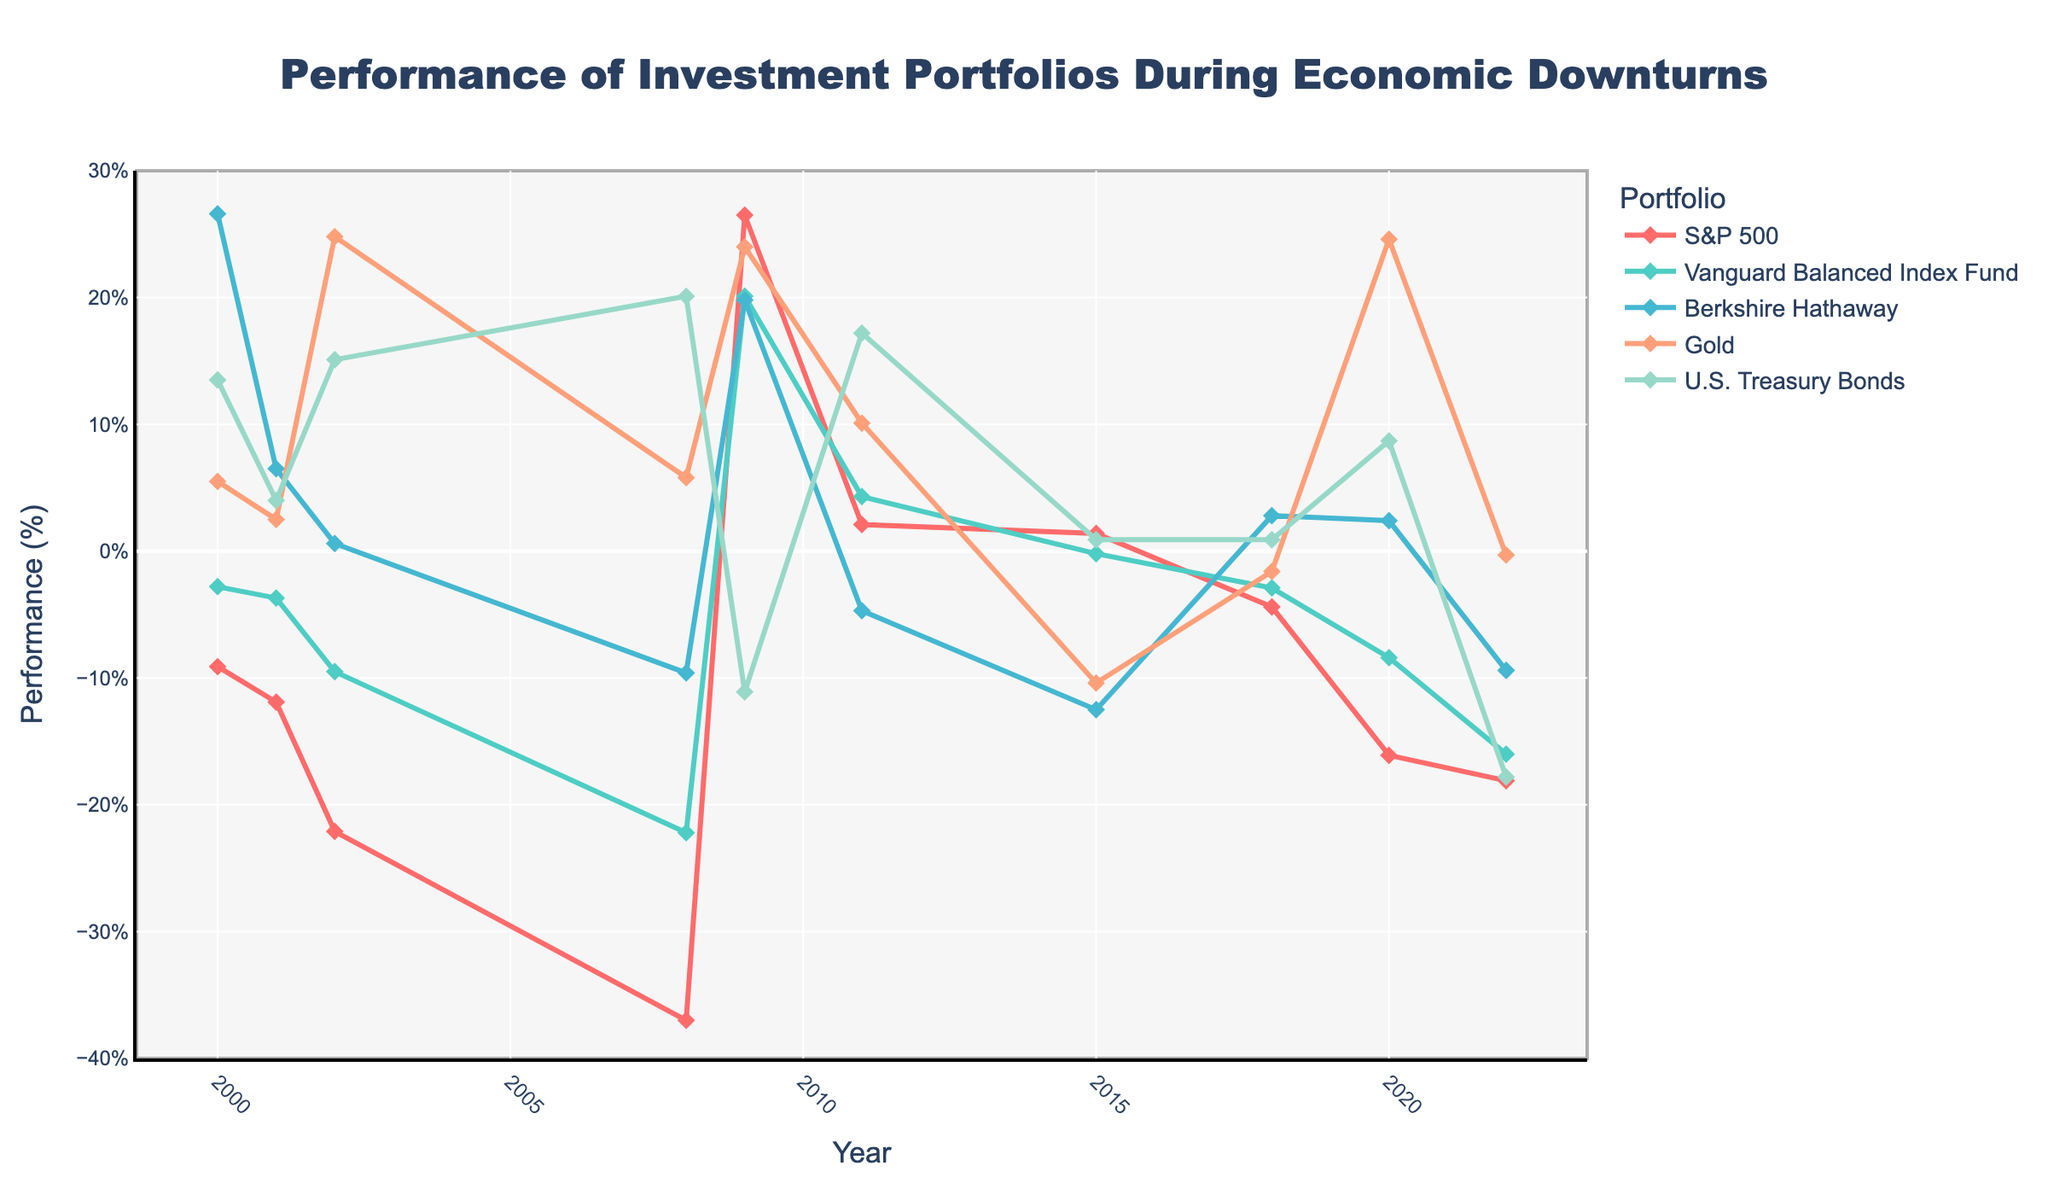Which portfolio had the highest performance in the year 2009? In the year 2009, inspect the data points for all portfolios. The one with the highest performance is the S&P 500 with a performance of 26.5%.
Answer: S&P 500 How did the performance of U.S. Treasury Bonds change from 2008 to 2009? Compare the U.S. Treasury Bonds data points for 2008 and 2009. In 2008, the performance was 20.1%, and in 2009, it was -11.1%. The performance decreased significantly.
Answer: Decreased What was the average performance of the Berkshire Hathaway portfolio during the highlighted years? Calculate the average by summing up the Berkshire Hathaway performances (-9.6, 19.8, -4.7, -12.5, 2.8, 2.4, -9.4) and dividing by the number of years (7). The sum is -11.2, and the average is -1.6%.
Answer: -1.6% Which year had the lowest performance for the S&P 500 portfolio? Look at the S&P 500 data points across all years. The lowest performance is -37.0% in the year 2008.
Answer: 2008 Compare the performance of Gold and U.S. Treasury Bonds in 2002. Which one performed better? For the year 2002, the performance of Gold is 24.8% and U.S. Treasury Bonds is 15.1%. Gold performed better.
Answer: Gold In how many years did Vanguard Balanced Index Fund perform better than the S&P 500? Compare the performance values for each year to see when the Vanguard Balanced Index Fund outperforms the S&P 500: 2000 (yes), 2002 (yes), 2008 (yes), 2011 (yes), 2018 (yes), and 2022 (yes). Six years in total.
Answer: Six years What is the trend of Gold's performance from 2018 to 2020? Check the data points for Gold from 2018 (-1.6%), 2019 (24.6%). The performance shows an increasing trend over these years.
Answer: Increasing Which portfolio had a negative performance for the most number of years? Count the number of years with negative performance for each portfolio. S&P 500 had negative performance in 6 years (-9.1, -11.9, -22.1, -37.0, -4.4, -16.1, -18.1).
Answer: S&P 500 What was the performance difference between Berkshire Hathaway and Gold in 2001? Subtract the performance of Gold (2.5%) from Berkshire Hathaway (6.5%) in 2001. The difference is 4.0%.
Answer: 4.0% Between 2000 and 2011, which year saw the highest performance for Vanguard Balanced Index Fund? Look at the Vanguard Balanced Index Fund performance data between 2000 and 2011. The highest performance was 4.3% in 2011.
Answer: 2011 